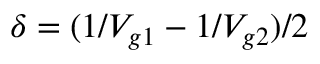<formula> <loc_0><loc_0><loc_500><loc_500>\delta = ( 1 / V _ { g 1 } - 1 / V _ { g 2 } ) / 2</formula> 